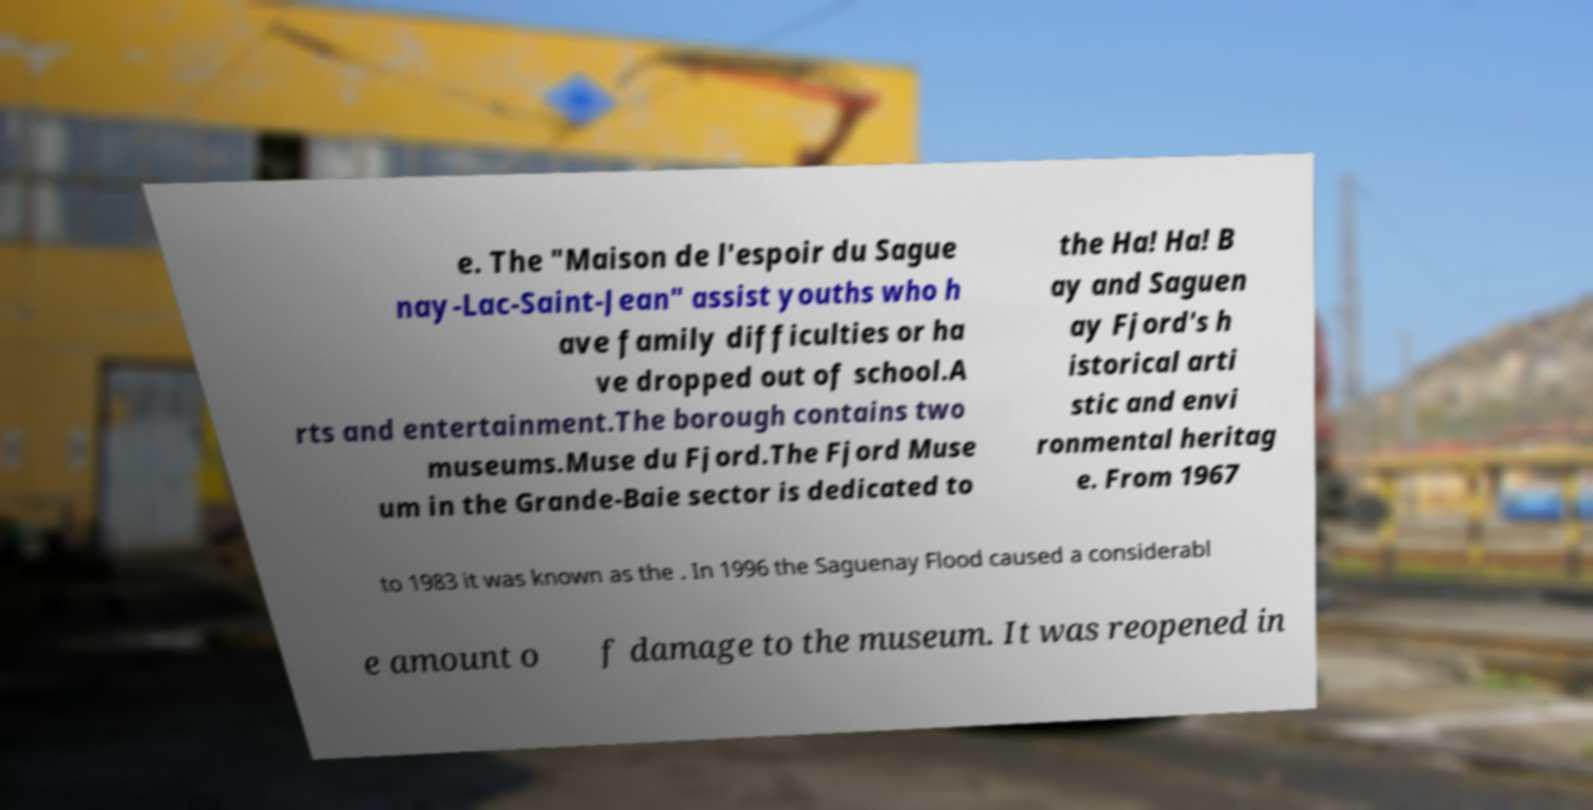Please identify and transcribe the text found in this image. e. The "Maison de l'espoir du Sague nay-Lac-Saint-Jean" assist youths who h ave family difficulties or ha ve dropped out of school.A rts and entertainment.The borough contains two museums.Muse du Fjord.The Fjord Muse um in the Grande-Baie sector is dedicated to the Ha! Ha! B ay and Saguen ay Fjord's h istorical arti stic and envi ronmental heritag e. From 1967 to 1983 it was known as the . In 1996 the Saguenay Flood caused a considerabl e amount o f damage to the museum. It was reopened in 